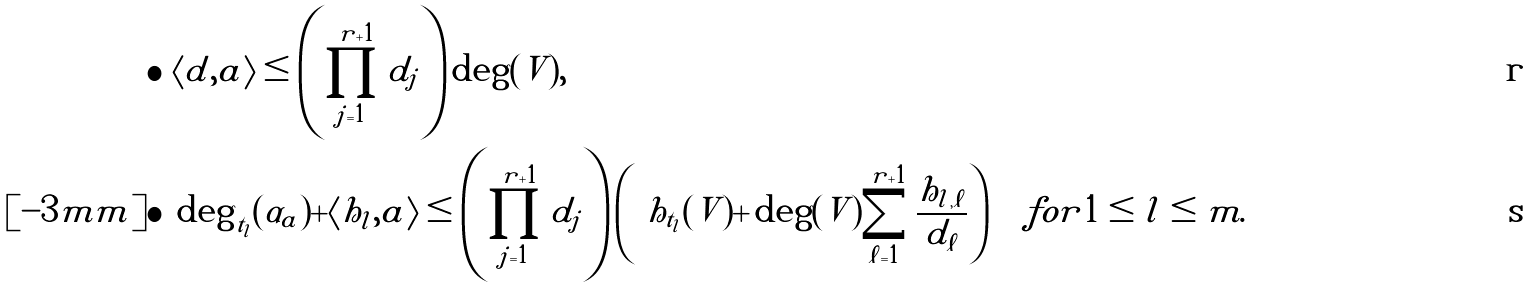<formula> <loc_0><loc_0><loc_500><loc_500>\bullet & \ \langle d , a \rangle \leq \left ( \prod _ { j = 1 } ^ { r + 1 } d _ { j } \right ) \deg ( V ) , \\ [ - 3 m m ] \bullet & \ \deg _ { t _ { l } } ( \alpha _ { a } ) + \langle h _ { l } , a \rangle \leq \left ( \prod _ { j = 1 } ^ { r + 1 } d _ { j } \right ) \left ( \ h _ { t _ { l } } ( V ) + \deg ( V ) \sum _ { \ell = 1 } ^ { r + 1 } \frac { h _ { l , \ell } } { d _ { \ell } } \right ) \quad f o r 1 \leq l \leq m .</formula> 